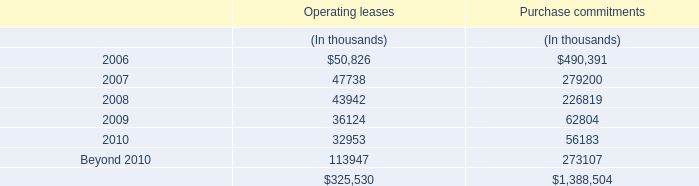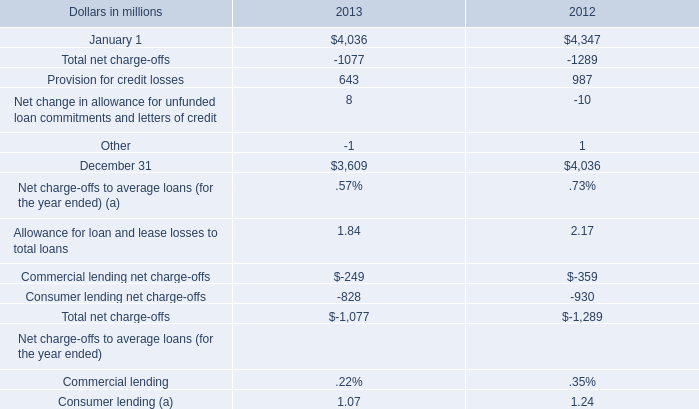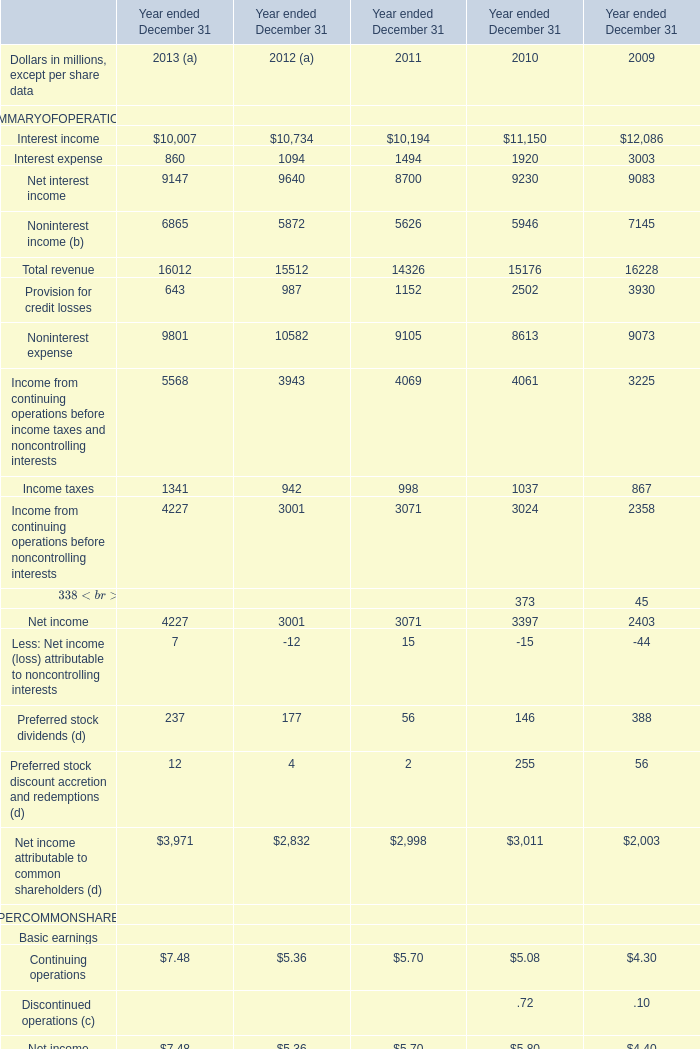What was the total amount of Net interest incomeNoninterest income (b)Total revenueProvision for credit losses in 2013? (in million) 
Computations: (((9147 + 6865) + 16012) + 643)
Answer: 32667.0. 